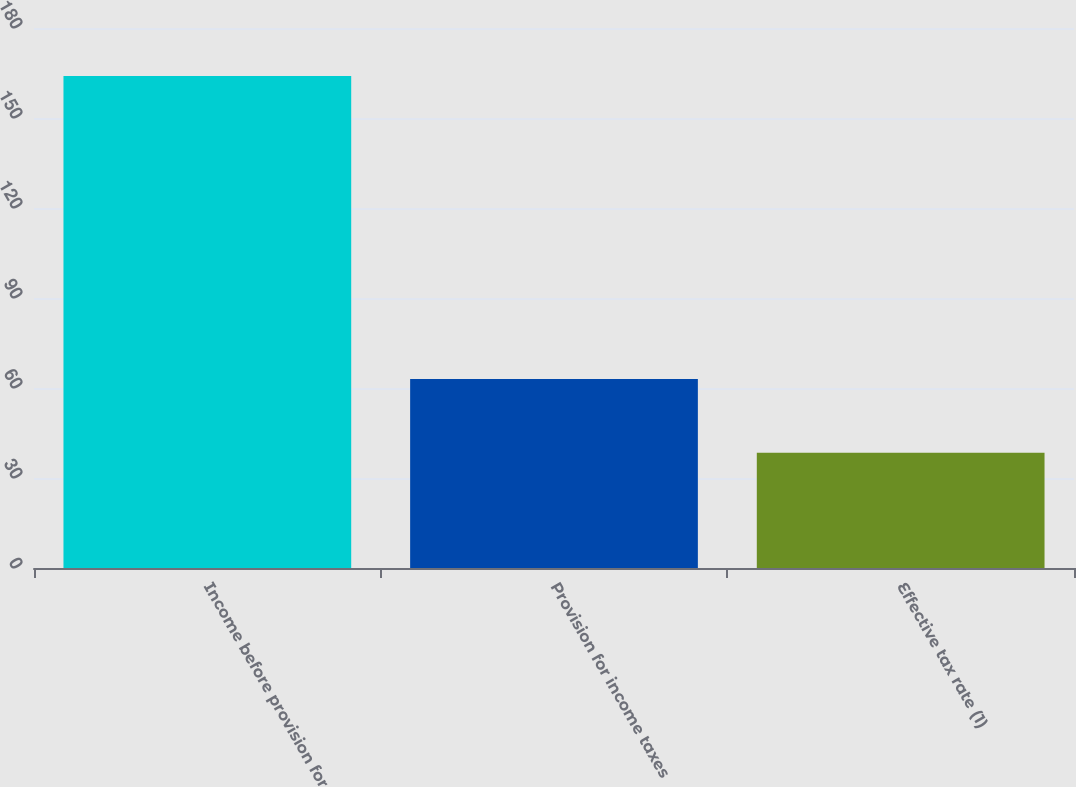Convert chart to OTSL. <chart><loc_0><loc_0><loc_500><loc_500><bar_chart><fcel>Income before provision for<fcel>Provision for income taxes<fcel>Effective tax rate (1)<nl><fcel>164<fcel>63<fcel>38.4<nl></chart> 